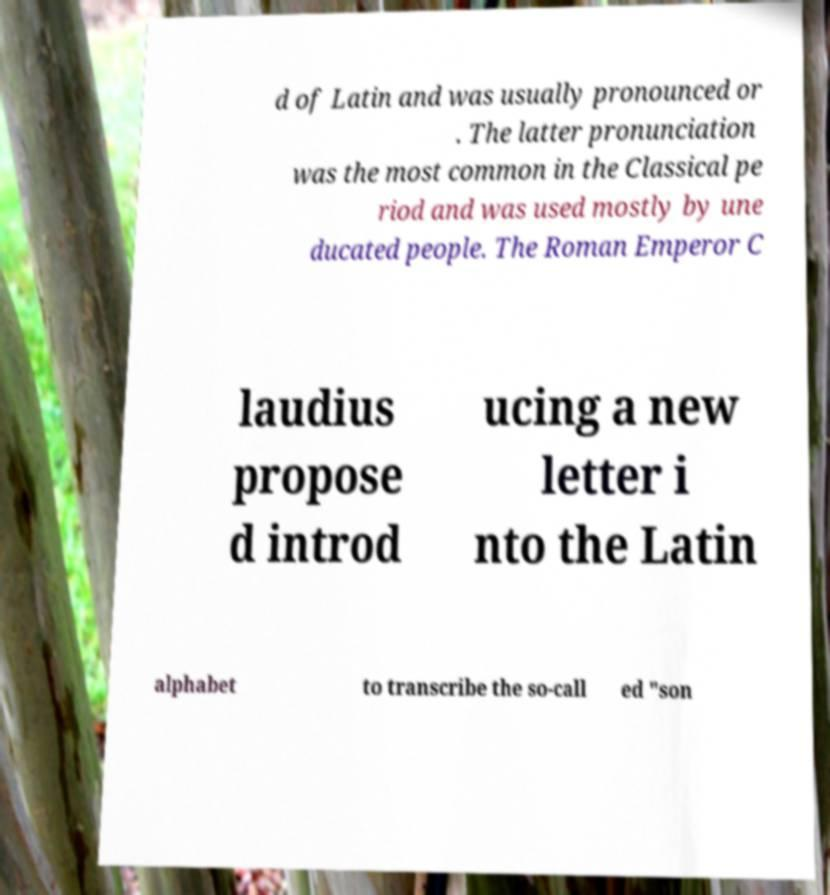There's text embedded in this image that I need extracted. Can you transcribe it verbatim? d of Latin and was usually pronounced or . The latter pronunciation was the most common in the Classical pe riod and was used mostly by une ducated people. The Roman Emperor C laudius propose d introd ucing a new letter i nto the Latin alphabet to transcribe the so-call ed "son 